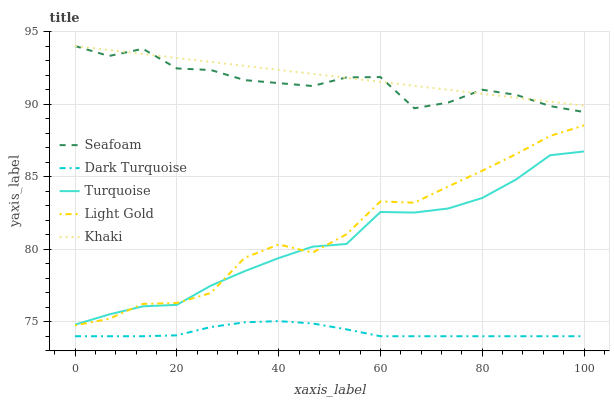Does Dark Turquoise have the minimum area under the curve?
Answer yes or no. Yes. Does Khaki have the maximum area under the curve?
Answer yes or no. Yes. Does Turquoise have the minimum area under the curve?
Answer yes or no. No. Does Turquoise have the maximum area under the curve?
Answer yes or no. No. Is Khaki the smoothest?
Answer yes or no. Yes. Is Light Gold the roughest?
Answer yes or no. Yes. Is Turquoise the smoothest?
Answer yes or no. No. Is Turquoise the roughest?
Answer yes or no. No. Does Turquoise have the lowest value?
Answer yes or no. No. Does Seafoam have the highest value?
Answer yes or no. Yes. Does Turquoise have the highest value?
Answer yes or no. No. Is Turquoise less than Khaki?
Answer yes or no. Yes. Is Khaki greater than Light Gold?
Answer yes or no. Yes. Does Khaki intersect Seafoam?
Answer yes or no. Yes. Is Khaki less than Seafoam?
Answer yes or no. No. Is Khaki greater than Seafoam?
Answer yes or no. No. Does Turquoise intersect Khaki?
Answer yes or no. No. 